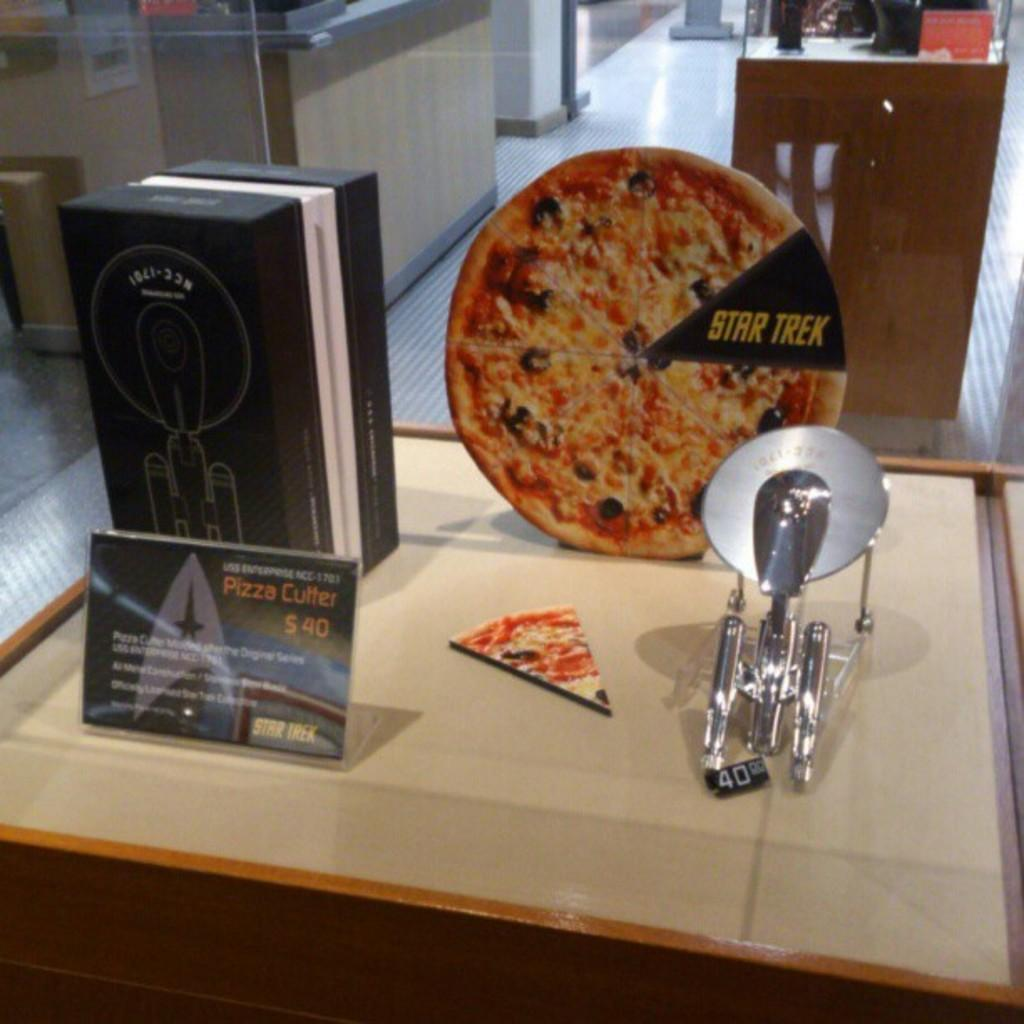What is the main object in the center of the image? There is a desk in the center of the image. What is placed on the desk? There is a box and a pizza poster on the desk. Can you describe the other furniture in the image? There is another table at the top side of the image. How many ladybugs can be seen crawling on the pizza poster in the image? There are no ladybugs present in the image, and therefore no such activity can be observed. 